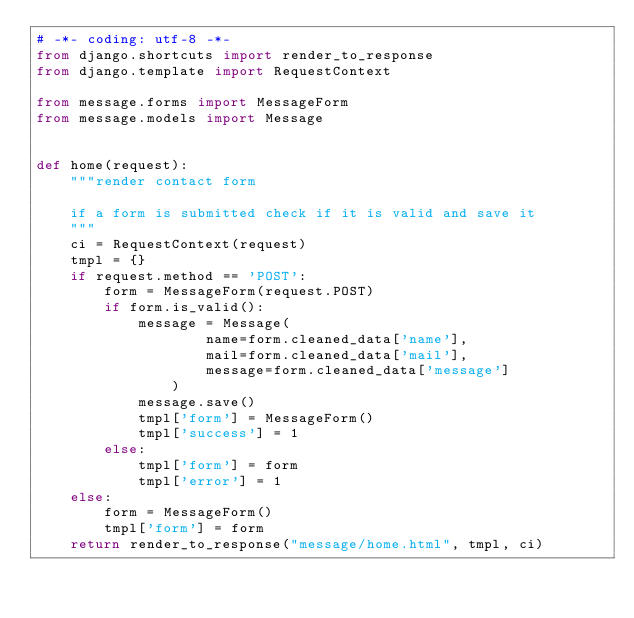<code> <loc_0><loc_0><loc_500><loc_500><_Python_># -*- coding: utf-8 -*-
from django.shortcuts import render_to_response
from django.template import RequestContext

from message.forms import MessageForm
from message.models import Message


def home(request):
    """render contact form

    if a form is submitted check if it is valid and save it
    """
    ci = RequestContext(request)
    tmpl = {}
    if request.method == 'POST':
        form = MessageForm(request.POST)
        if form.is_valid():
            message = Message(
                    name=form.cleaned_data['name'],
                    mail=form.cleaned_data['mail'],
                    message=form.cleaned_data['message']
                )
            message.save()
            tmpl['form'] = MessageForm()
            tmpl['success'] = 1
        else:
            tmpl['form'] = form
            tmpl['error'] = 1
    else:
        form = MessageForm()
        tmpl['form'] = form
    return render_to_response("message/home.html", tmpl, ci)
</code> 